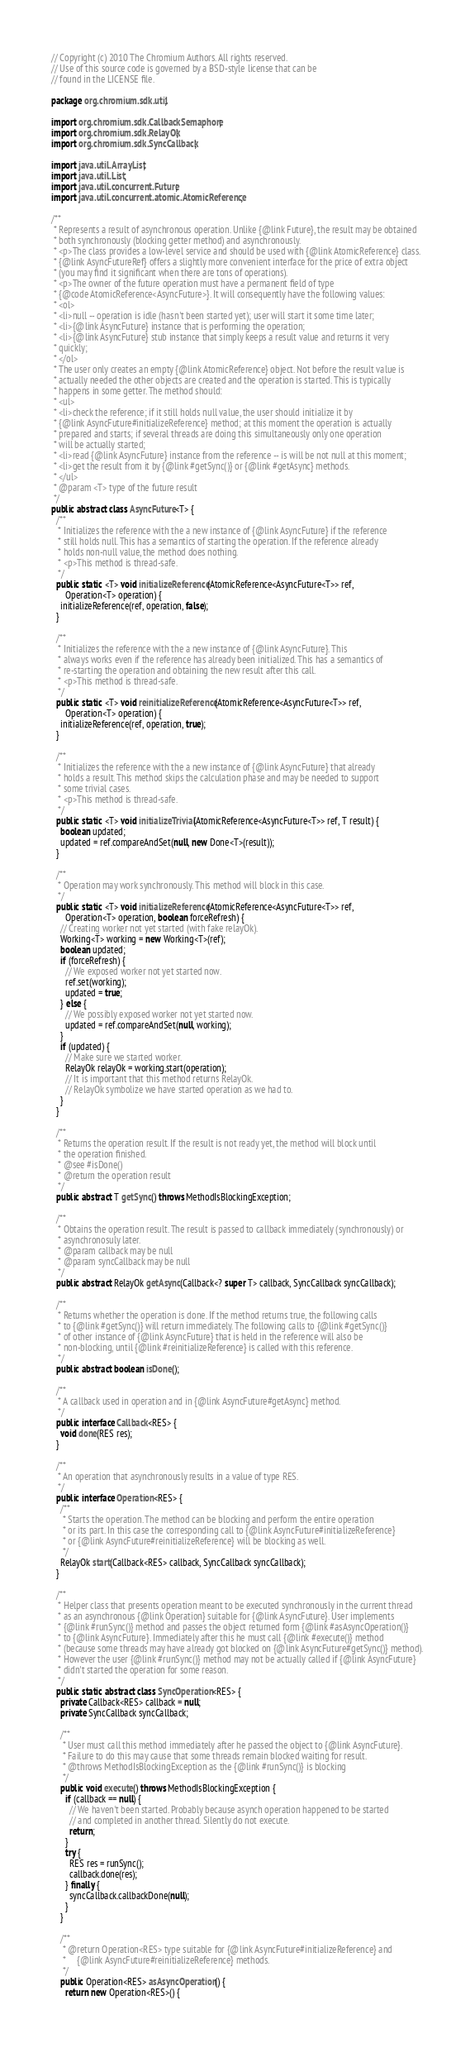<code> <loc_0><loc_0><loc_500><loc_500><_Java_>// Copyright (c) 2010 The Chromium Authors. All rights reserved.
// Use of this source code is governed by a BSD-style license that can be
// found in the LICENSE file.

package org.chromium.sdk.util;

import org.chromium.sdk.CallbackSemaphore;
import org.chromium.sdk.RelayOk;
import org.chromium.sdk.SyncCallback;

import java.util.ArrayList;
import java.util.List;
import java.util.concurrent.Future;
import java.util.concurrent.atomic.AtomicReference;

/**
 * Represents a result of asynchronous operation. Unlike {@link Future}, the result may be obtained
 * both synchronously (blocking getter method) and asynchronously.
 * <p>The class provides a low-level service and should be used with {@link AtomicReference} class.
 * {@link AsyncFutureRef} offers a slightly more convenient interface for the price of extra object
 * (you may find it significant when there are tons of operations).
 * <p>The owner of the future operation must have a permanent field of type
 * {@code AtomicReference<AsyncFuture>}. It will consequently have the following values:
 * <ol>
 * <li>null -- operation is idle (hasn't been started yet); user will start it some time later;
 * <li>{@link AsyncFuture} instance that is performing the operation;
 * <li>{@link AsyncFuture} stub instance that simply keeps a result value and returns it very
 * quickly;
 * </ol>
 * The user only creates an empty {@link AtomicReference} object. Not before the result value is
 * actually needed the other objects are created and the operation is started. This is typically
 * happens in some getter. The method should:
 * <ul>
 * <li>check the reference; if it still holds null value, the user should initialize it by
 * {@link AsyncFuture#initializeReference} method; at this moment the operation is actually
 * prepared and starts; if several threads are doing this simultaneously only one operation
 * will be actually started;
 * <li>read {@link AsyncFuture} instance from the reference -- is will be not null at this moment;
 * <li>get the result from it by {@link #getSync()} or {@link #getAsync} methods.
 * </ul>
 * @param <T> type of the future result
 */
public abstract class AsyncFuture<T> {
  /**
   * Initializes the reference with the a new instance of {@link AsyncFuture} if the reference
   * still holds null. This has a semantics of starting the operation. If the reference already
   * holds non-null value, the method does nothing.
   * <p>This method is thread-safe.
   */
  public static <T> void initializeReference(AtomicReference<AsyncFuture<T>> ref,
      Operation<T> operation) {
    initializeReference(ref, operation, false);
  }

  /**
   * Initializes the reference with the a new instance of {@link AsyncFuture}. This
   * always works even if the reference has already been initialized. This has a semantics of
   * re-starting the operation and obtaining the new result after this call.
   * <p>This method is thread-safe.
   */
  public static <T> void reinitializeReference(AtomicReference<AsyncFuture<T>> ref,
      Operation<T> operation) {
    initializeReference(ref, operation, true);
  }

  /**
   * Initializes the reference with the a new instance of {@link AsyncFuture} that already
   * holds a result. This method skips the calculation phase and may be needed to support
   * some trivial cases.
   * <p>This method is thread-safe.
   */
  public static <T> void initializeTrivial(AtomicReference<AsyncFuture<T>> ref, T result) {
    boolean updated;
    updated = ref.compareAndSet(null, new Done<T>(result));
  }

  /**
   * Operation may work synchronously. This method will block in this case.
   */
  public static <T> void initializeReference(AtomicReference<AsyncFuture<T>> ref,
      Operation<T> operation, boolean forceRefresh) {
    // Creating worker not yet started (with fake relayOk).
    Working<T> working = new Working<T>(ref);
    boolean updated;
    if (forceRefresh) {
      // We exposed worker not yet started now.
      ref.set(working);
      updated = true;
    } else {
      // We possibly exposed worker not yet started now.
      updated = ref.compareAndSet(null, working);
    }
    if (updated) {
      // Make sure we started worker.
      RelayOk relayOk = working.start(operation);
      // It is important that this method returns RelayOk.
      // RelayOk symbolize we have started operation as we had to.
    }
  }

  /**
   * Returns the operation result. If the result is not ready yet, the method will block until
   * the operation finished.
   * @see #isDone()
   * @return the operation result
   */
  public abstract T getSync() throws MethodIsBlockingException;

  /**
   * Obtains the operation result. The result is passed to callback immediately (synchronously) or
   * asynchronosuly later.
   * @param callback may be null
   * @param syncCallback may be null
   */
  public abstract RelayOk getAsync(Callback<? super T> callback, SyncCallback syncCallback);

  /**
   * Returns whether the operation is done. If the method returns true, the following calls
   * to {@link #getSync()} will return immediately. The following calls to {@link #getSync()}
   * of other instance of {@link AsyncFuture} that is held in the reference will also be
   * non-blocking, until {@link #reinitializeReference} is called with this reference.
   */
  public abstract boolean isDone();

  /**
   * A callback used in operation and in {@link AsyncFuture#getAsync} method.
   */
  public interface Callback<RES> {
    void done(RES res);
  }

  /**
   * An operation that asynchronously results in a value of type RES.
   */
  public interface Operation<RES> {
    /**
     * Starts the operation. The method can be blocking and perform the entire operation
     * or its part. In this case the corresponding call to {@link AsyncFuture#initializeReference}
     * or {@link AsyncFuture#reinitializeReference} will be blocking as well.
     */
    RelayOk start(Callback<RES> callback, SyncCallback syncCallback);
  }

  /**
   * Helper class that presents operation meant to be executed synchronously in the current thread
   * as an asynchronous {@link Operation} suitable for {@link AsyncFuture}. User implements
   * {@link #runSync()} method and passes the object returned form {@link #asAsyncOperation()}
   * to {@link AsyncFuture}. Immediately after this he must call {@link #execute()} method
   * (because some threads may have already got blocked on {@link AsyncFuture#getSync()} method).
   * However the user {@link #runSync()} method may not be actually called if {@link AsyncFuture}
   * didn't started the operation for some reason.
   */
  public static abstract class SyncOperation<RES> {
    private Callback<RES> callback = null;
    private SyncCallback syncCallback;

    /**
     * User must call this method immediately after he passed the object to {@link AsyncFuture}.
     * Failure to do this may cause that some threads remain blocked waiting for result.
     * @throws MethodIsBlockingException as the {@link #runSync()} is blocking
     */
    public void execute() throws MethodIsBlockingException {
      if (callback == null) {
        // We haven't been started. Probably because asynch operation happened to be started
        // and completed in another thread. Silently do not execute.
        return;
      }
      try {
        RES res = runSync();
        callback.done(res);
      } finally {
        syncCallback.callbackDone(null);
      }
    }

    /**
     * @return Operation<RES> type suitable for {@link AsyncFuture#initializeReference} and
     *     {@link AsyncFuture#reinitializeReference} methods.
     */
    public Operation<RES> asAsyncOperation() {
      return new Operation<RES>() {</code> 